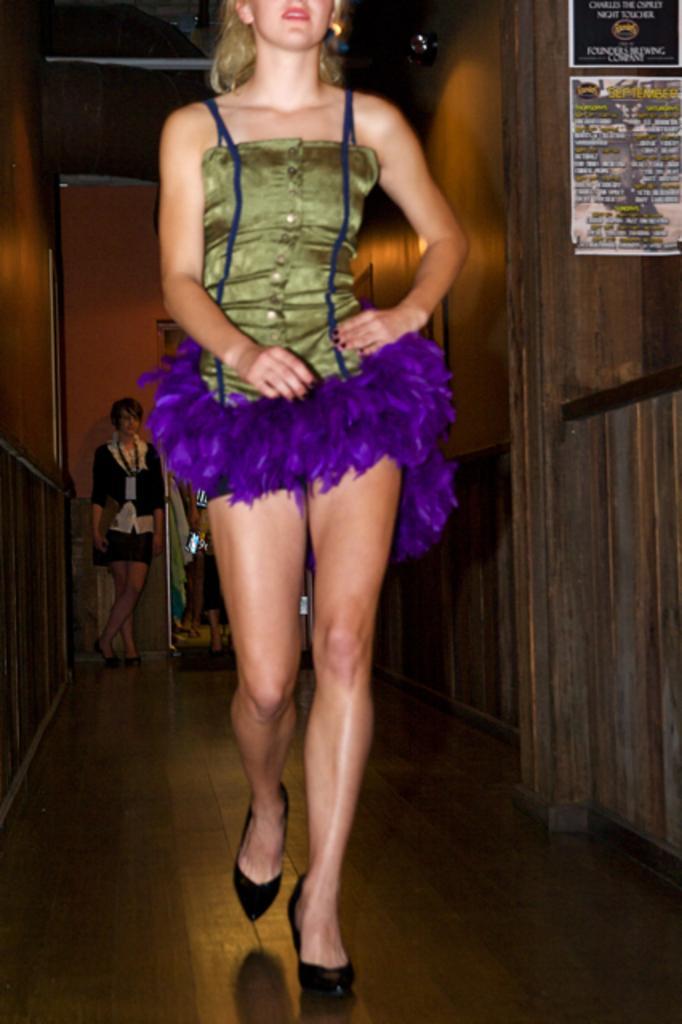Please provide a concise description of this image. In this image we can see a person walking on the floor. On the right side of the image there is a wall and a name board. In the background of the image there is a person, wall and other objects. 